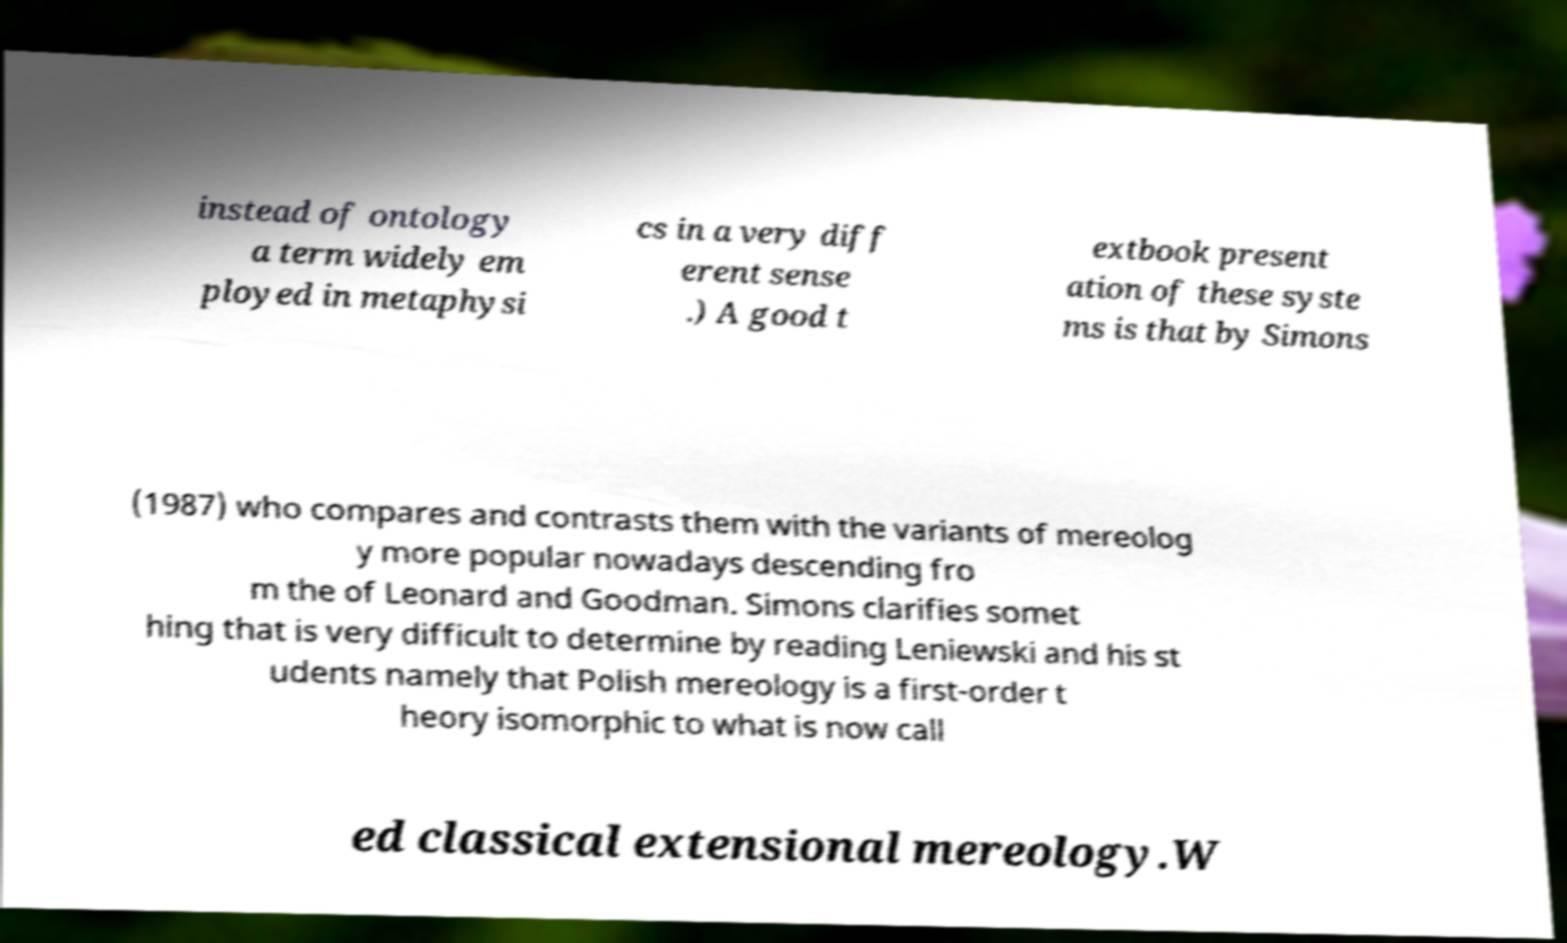Can you accurately transcribe the text from the provided image for me? instead of ontology a term widely em ployed in metaphysi cs in a very diff erent sense .) A good t extbook present ation of these syste ms is that by Simons (1987) who compares and contrasts them with the variants of mereolog y more popular nowadays descending fro m the of Leonard and Goodman. Simons clarifies somet hing that is very difficult to determine by reading Leniewski and his st udents namely that Polish mereology is a first-order t heory isomorphic to what is now call ed classical extensional mereology.W 